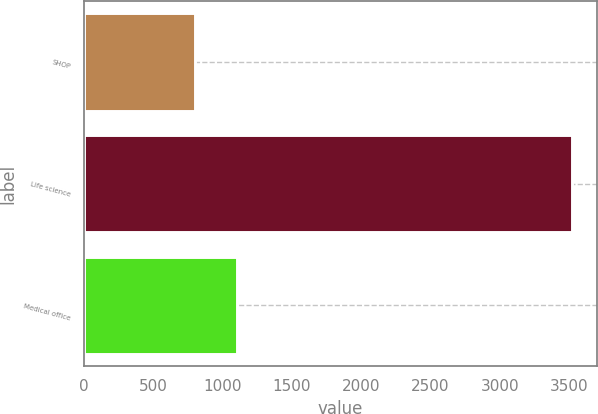Convert chart to OTSL. <chart><loc_0><loc_0><loc_500><loc_500><bar_chart><fcel>SHOP<fcel>Life science<fcel>Medical office<nl><fcel>797<fcel>3524<fcel>1104<nl></chart> 